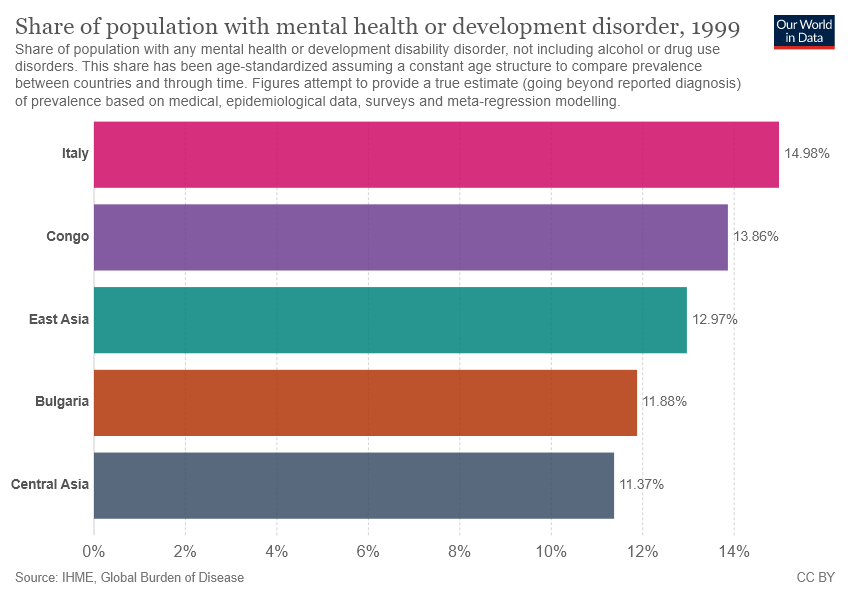Outline some significant characteristics in this image. According to the data, Central Asia has the lowest value among all countries and areas. The average of all areas is 13.012... 